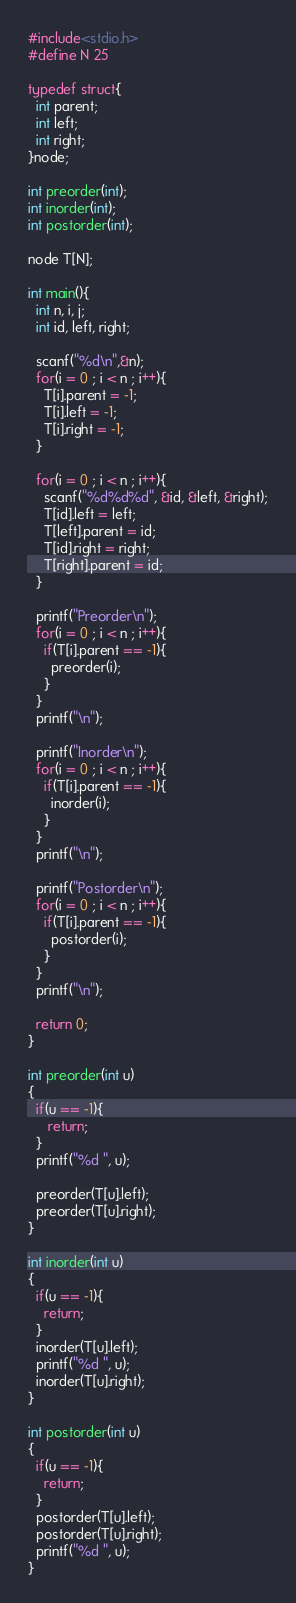Convert code to text. <code><loc_0><loc_0><loc_500><loc_500><_C_>#include<stdio.h>
#define N 25

typedef struct{
  int parent;
  int left;
  int right;
}node;

int preorder(int);
int inorder(int);
int postorder(int);

node T[N];

int main(){
  int n, i, j;
  int id, left, right;

  scanf("%d\n",&n);
  for(i = 0 ; i < n ; i++){
    T[i].parent = -1;
    T[i].left = -1;
    T[i].right = -1;
  }

  for(i = 0 ; i < n ; i++){
    scanf("%d%d%d", &id, &left, &right);
    T[id].left = left;
    T[left].parent = id;
    T[id].right = right;
    T[right].parent = id;
  }

  printf("Preorder\n");
  for(i = 0 ; i < n ; i++){
    if(T[i].parent == -1){
      preorder(i);
    }
  }
  printf("\n");

  printf("Inorder\n");
  for(i = 0 ; i < n ; i++){
    if(T[i].parent == -1){
      inorder(i);
    }
  }
  printf("\n");

  printf("Postorder\n");
  for(i = 0 ; i < n ; i++){
    if(T[i].parent == -1){
      postorder(i);
    }
  }
  printf("\n");
    
  return 0;
}

int preorder(int u)
{
  if(u == -1){
     return;
  }
  printf("%d ", u);
  
  preorder(T[u].left);
  preorder(T[u].right);
}

int inorder(int u)
{
  if(u == -1){
    return;
  }
  inorder(T[u].left);
  printf("%d ", u);
  inorder(T[u].right);
}

int postorder(int u)
{
  if(u == -1){
    return;
  }
  postorder(T[u].left);
  postorder(T[u].right);
  printf("%d ", u);
}</code> 